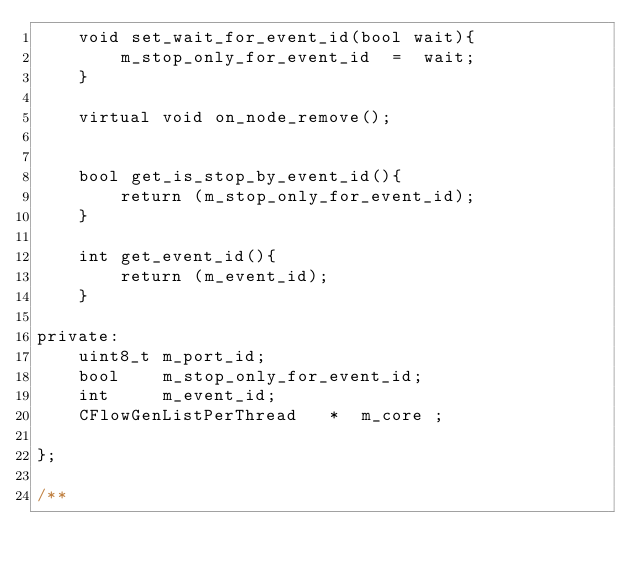<code> <loc_0><loc_0><loc_500><loc_500><_C_>    void set_wait_for_event_id(bool wait){
        m_stop_only_for_event_id  =  wait;
    }

    virtual void on_node_remove();


    bool get_is_stop_by_event_id(){
        return (m_stop_only_for_event_id);
    }

    int get_event_id(){
        return (m_event_id);
    }

private:
    uint8_t m_port_id;
    bool    m_stop_only_for_event_id;
    int     m_event_id;
    CFlowGenListPerThread   *  m_core ;

};

/**</code> 